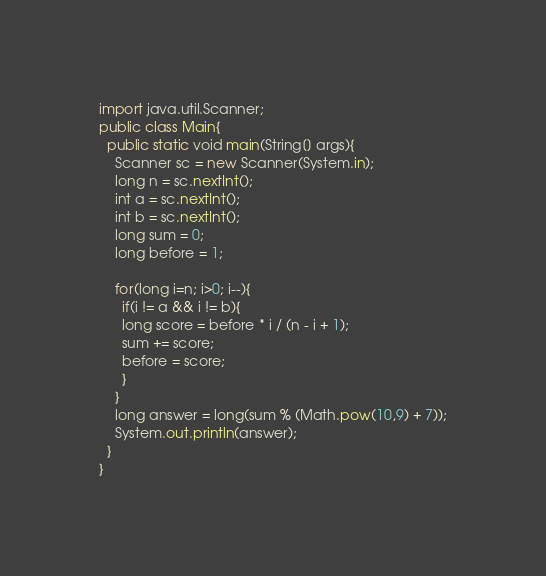Convert code to text. <code><loc_0><loc_0><loc_500><loc_500><_Java_>import java.util.Scanner;
public class Main{
  public static void main(String[] args){
	Scanner sc = new Scanner(System.in);
    long n = sc.nextInt();
    int a = sc.nextInt();
    int b = sc.nextInt();
    long sum = 0;
    long before = 1;
    
    for(long i=n; i>0; i--){
      if(i != a && i != b){
      long score = before * i / (n - i + 1);
      sum += score;
      before = score;  
      }
    } 
    long answer = long(sum % (Math.pow(10,9) + 7));
    System.out.println(answer);
  }
}
</code> 